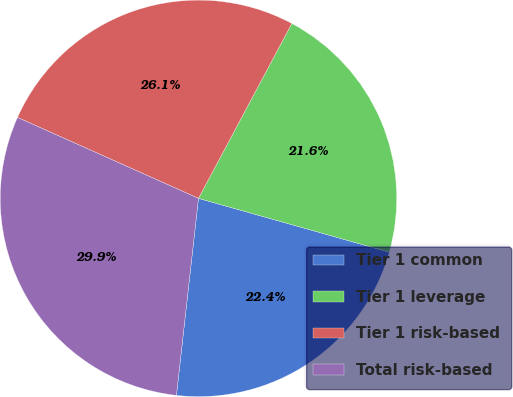Convert chart. <chart><loc_0><loc_0><loc_500><loc_500><pie_chart><fcel>Tier 1 common<fcel>Tier 1 leverage<fcel>Tier 1 risk-based<fcel>Total risk-based<nl><fcel>22.4%<fcel>21.57%<fcel>26.11%<fcel>29.92%<nl></chart> 